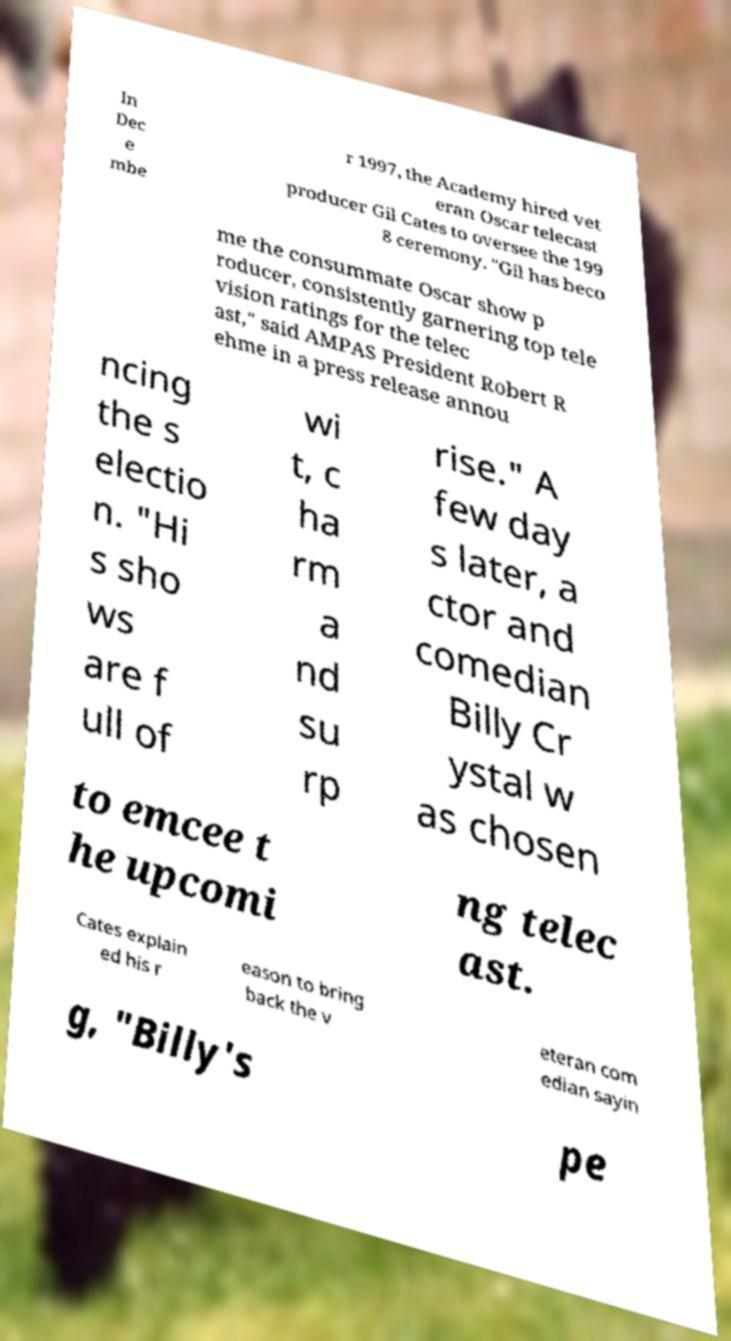What messages or text are displayed in this image? I need them in a readable, typed format. In Dec e mbe r 1997, the Academy hired vet eran Oscar telecast producer Gil Cates to oversee the 199 8 ceremony. "Gil has beco me the consummate Oscar show p roducer, consistently garnering top tele vision ratings for the telec ast," said AMPAS President Robert R ehme in a press release annou ncing the s electio n. "Hi s sho ws are f ull of wi t, c ha rm a nd su rp rise." A few day s later, a ctor and comedian Billy Cr ystal w as chosen to emcee t he upcomi ng telec ast. Cates explain ed his r eason to bring back the v eteran com edian sayin g, "Billy's pe 